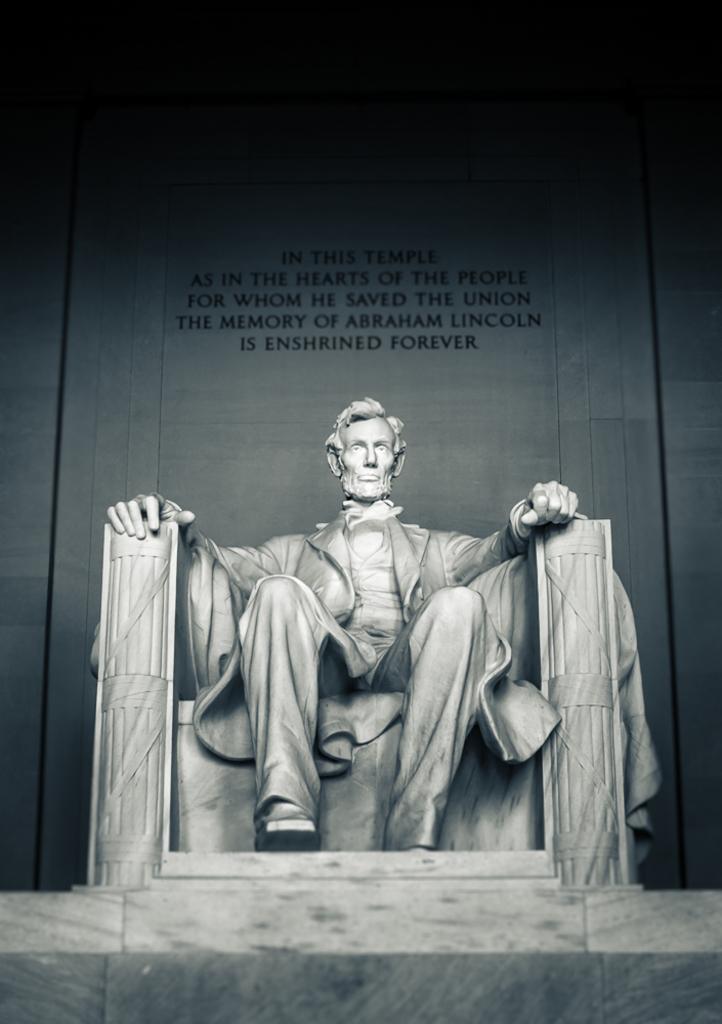In one or two sentences, can you explain what this image depicts? In this image there is a sculpture of man sitting in the chair, behind him there is a wall with some text. 